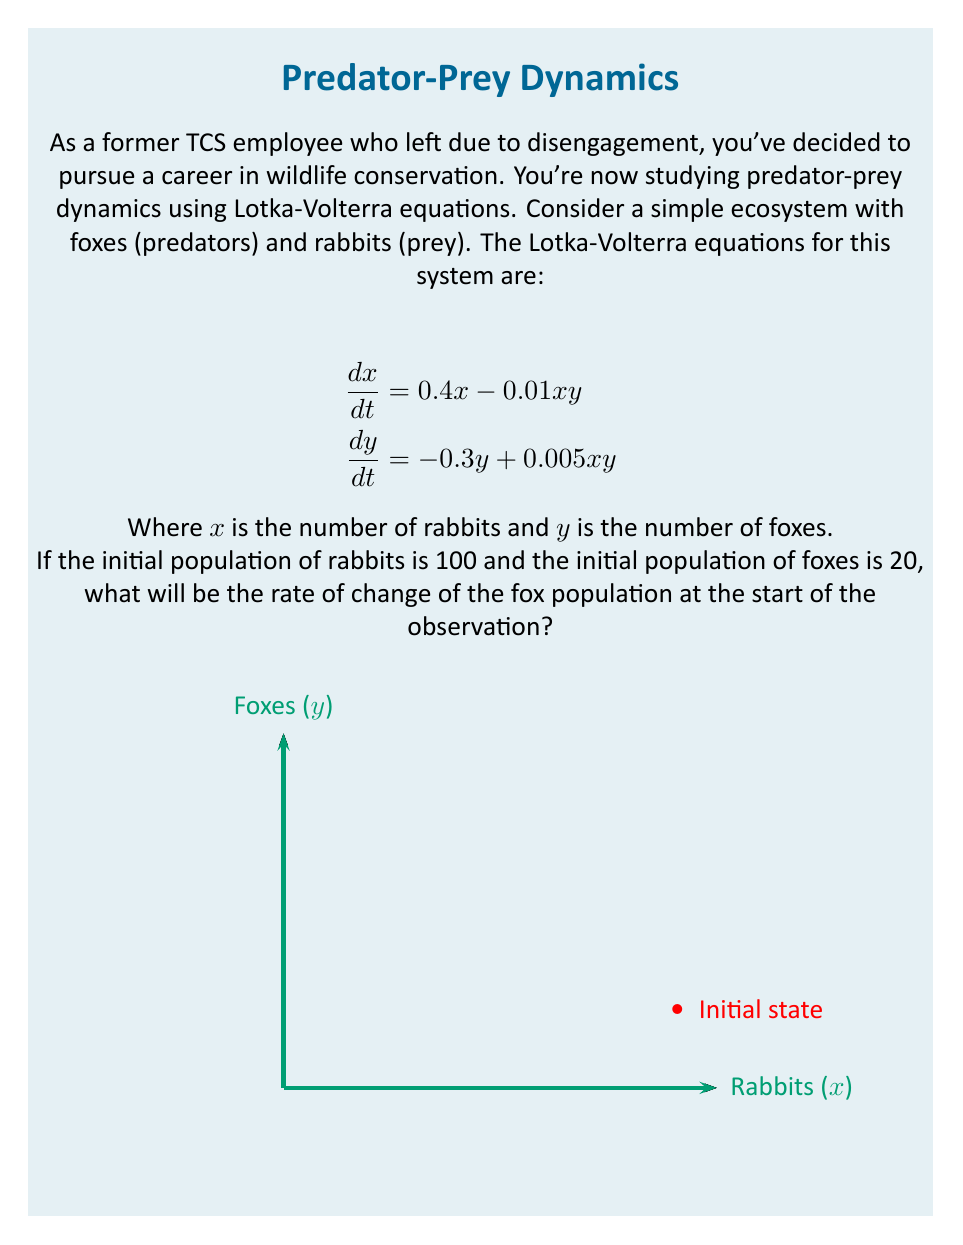Solve this math problem. To solve this problem, we'll use the Lotka-Volterra equation for the rate of change of the fox population:

$$\frac{dy}{dt} = -0.3y + 0.005xy$$

We need to substitute the initial values:
$x = 100$ (initial rabbit population)
$y = 20$ (initial fox population)

Let's calculate step by step:

1) Substitute the values into the equation:
   $$\frac{dy}{dt} = -0.3(20) + 0.005(100)(20)$$

2) Simplify the first term:
   $$\frac{dy}{dt} = -6 + 0.005(100)(20)$$

3) Multiply inside the parentheses:
   $$\frac{dy}{dt} = -6 + 0.005(2000)$$

4) Multiply:
   $$\frac{dy}{dt} = -6 + 10$$

5) Finally, add the terms:
   $$\frac{dy}{dt} = 4$$

Therefore, at the start of the observation, the rate of change of the fox population is 4 foxes per time unit.
Answer: 4 foxes per time unit 